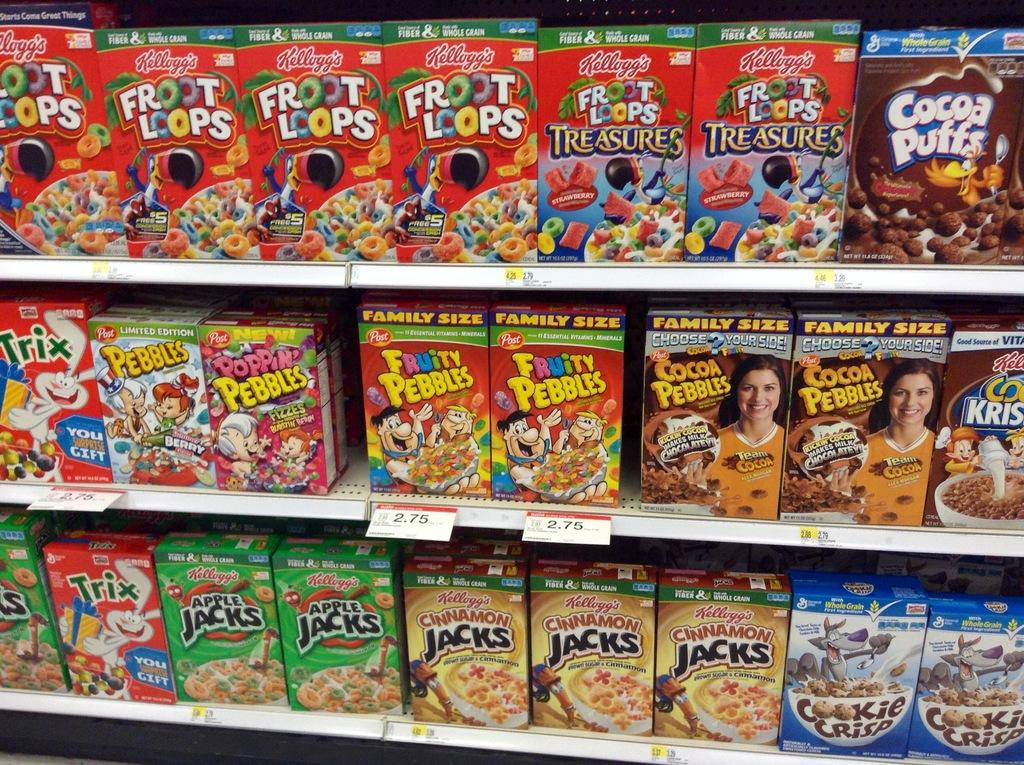<image>
Describe the image concisely. a display of cereal boxes, including Froot Loops and Fruity Pebbles 